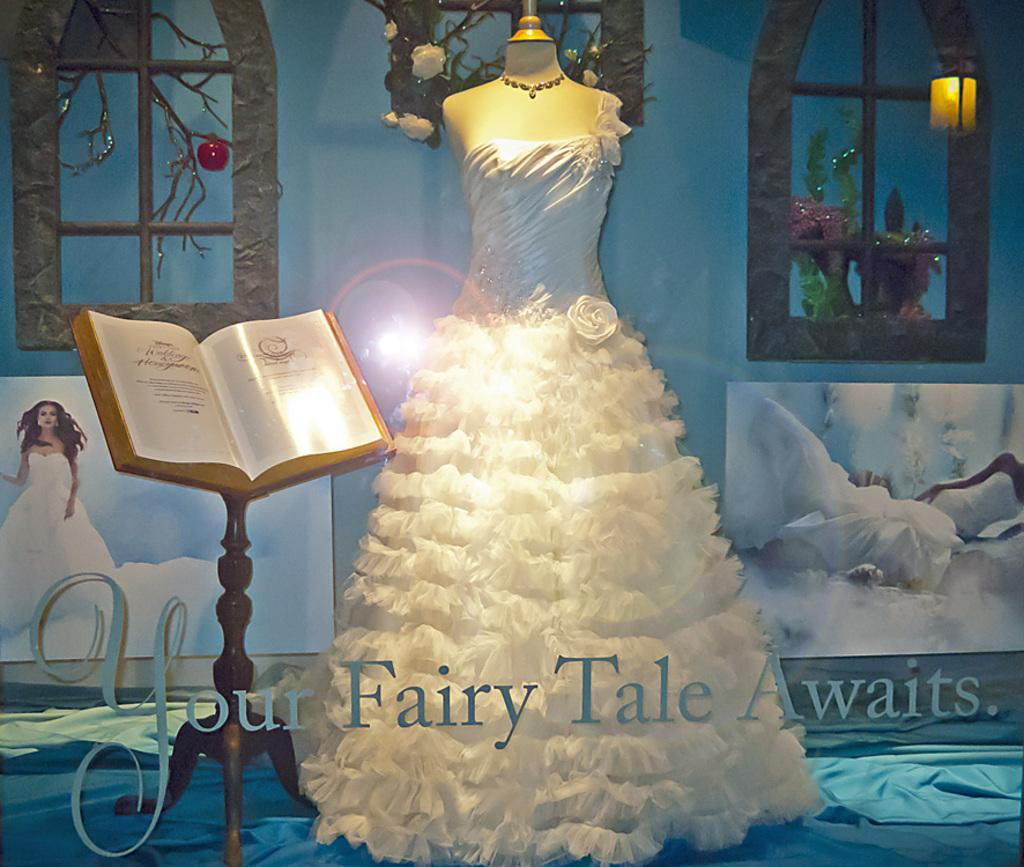What is the main subject of the image? There is a mannequin in the image. What is the mannequin wearing? The mannequin is wearing a gown. What else can be seen in the image besides the mannequin? There is a stand with a book in the image. What color is the lip of the mannequin in the image? The mannequin does not have a lip, as it is an inanimate object. 